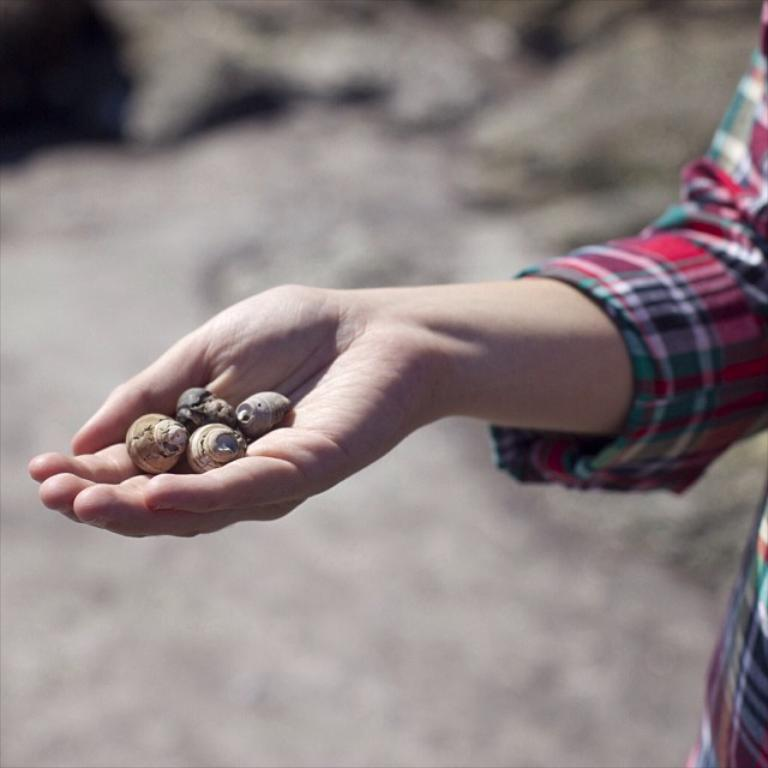Who or what is present in the image? There is a person in the image. What is the person holding in their hand? The person is holding stones in their hand. How does the person contribute to the development of the area in the image? The image does not provide any information about the person's contribution to the development of the area. 